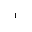Convert formula to latex. <formula><loc_0><loc_0><loc_500><loc_500>^ { - 1 }</formula> 